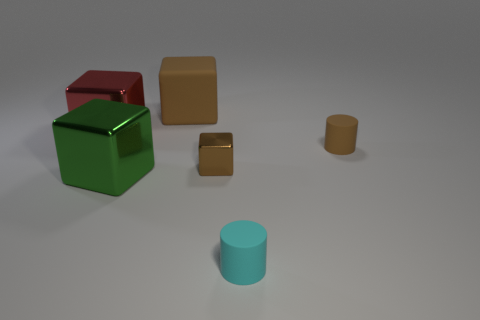There is a brown object behind the big block that is to the left of the big green cube; what is its material?
Offer a very short reply. Rubber. What color is the large matte thing?
Offer a very short reply. Brown. There is a object behind the red cube; is it the same color as the rubber object that is right of the tiny cyan matte cylinder?
Offer a terse response. Yes. What is the size of the cyan rubber object that is the same shape as the small brown matte object?
Your answer should be very brief. Small. Is there a tiny shiny object of the same color as the tiny metal block?
Provide a succinct answer. No. There is a tiny cylinder that is the same color as the tiny block; what is its material?
Provide a succinct answer. Rubber. How many matte objects have the same color as the tiny metallic cube?
Make the answer very short. 2. How many things are metal objects behind the large green block or small shiny blocks?
Make the answer very short. 2. What is the color of the other cylinder that is the same material as the small cyan cylinder?
Keep it short and to the point. Brown. Is there a cylinder that has the same size as the cyan thing?
Provide a short and direct response. Yes. 